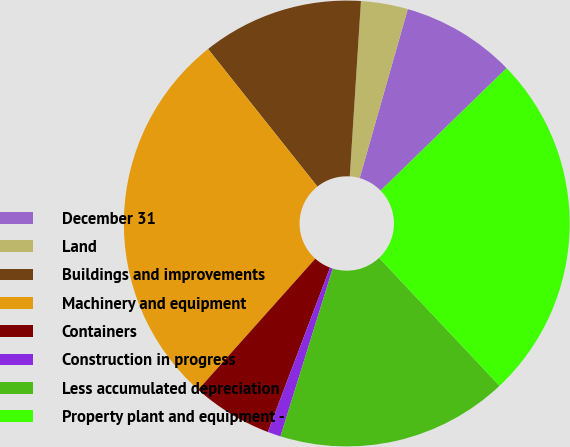Convert chart to OTSL. <chart><loc_0><loc_0><loc_500><loc_500><pie_chart><fcel>December 31<fcel>Land<fcel>Buildings and improvements<fcel>Machinery and equipment<fcel>Containers<fcel>Construction in progress<fcel>Less accumulated depreciation<fcel>Property plant and equipment -<nl><fcel>8.31%<fcel>3.4%<fcel>11.7%<fcel>27.7%<fcel>5.85%<fcel>0.95%<fcel>16.82%<fcel>25.25%<nl></chart> 